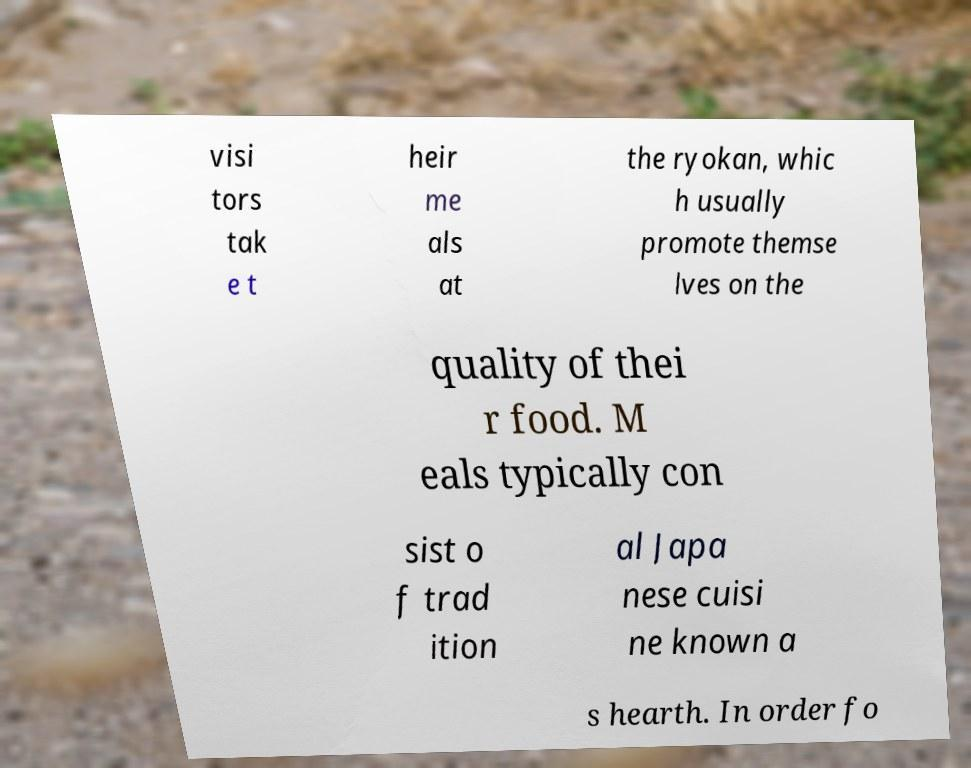Can you read and provide the text displayed in the image?This photo seems to have some interesting text. Can you extract and type it out for me? visi tors tak e t heir me als at the ryokan, whic h usually promote themse lves on the quality of thei r food. M eals typically con sist o f trad ition al Japa nese cuisi ne known a s hearth. In order fo 